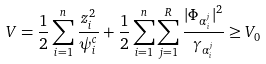<formula> <loc_0><loc_0><loc_500><loc_500>V = \frac { 1 } { 2 } \sum _ { i = 1 } ^ { n } \frac { z _ { i } ^ { 2 } } { \psi _ { i } ^ { c } } + \frac { 1 } { 2 } \sum _ { i = 1 } ^ { n } \sum _ { j = 1 } ^ { R } \frac { | \Phi _ { \alpha _ { i } ^ { j } } | ^ { 2 } } { \gamma _ { \alpha _ { i } ^ { j } } } \geq V _ { 0 }</formula> 